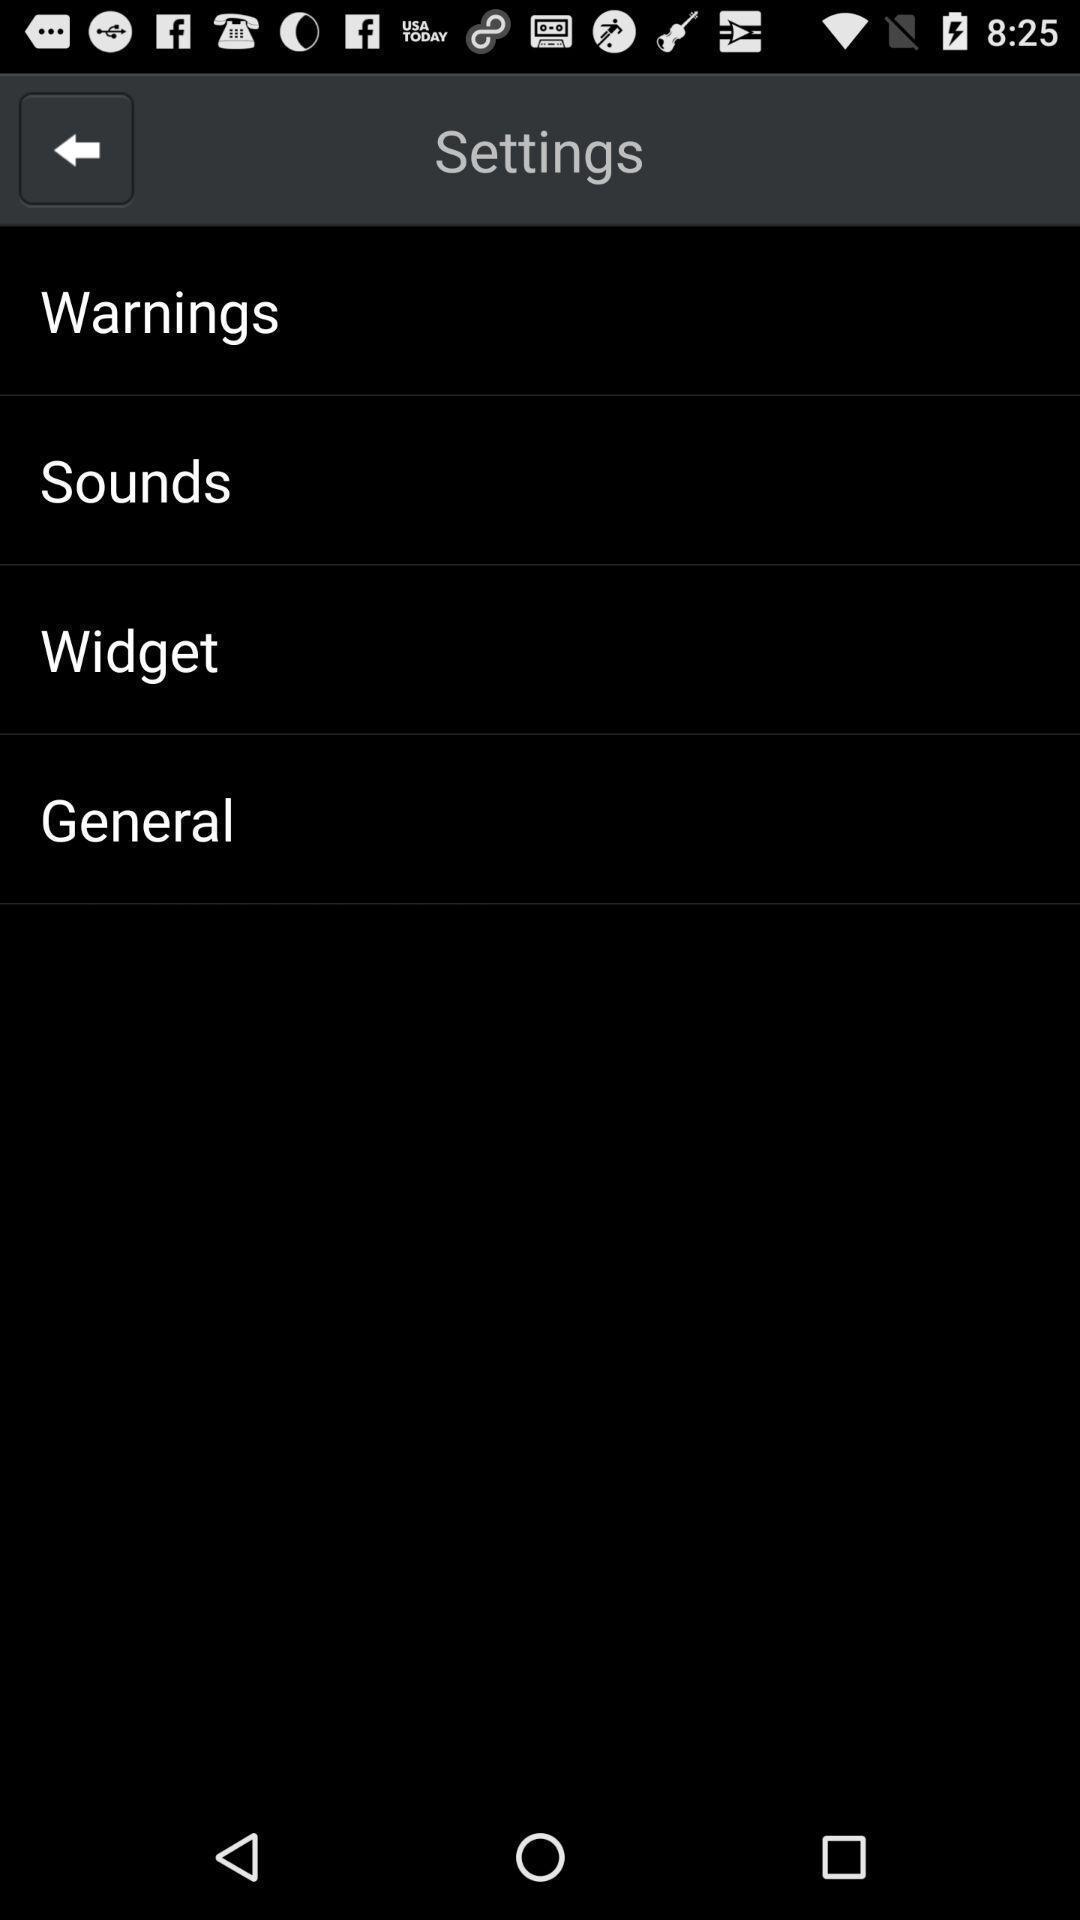Provide a textual representation of this image. Screen displaying multiple options in settings page. 